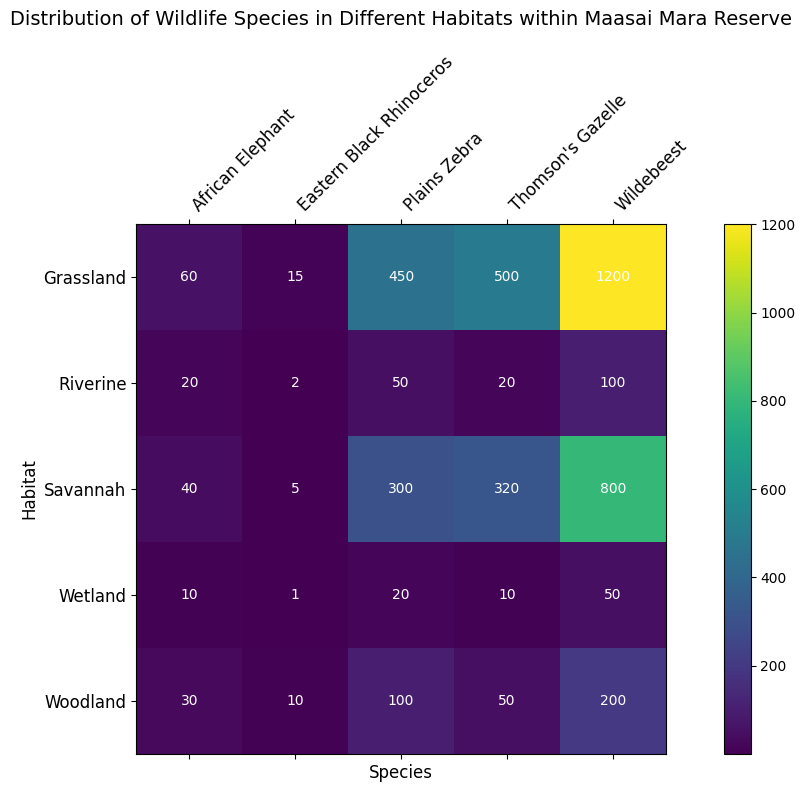What's the total count of all species in the Grassland habitat? In the Grassland row, sum the counts of all the species: 15 (Eastern Black Rhinoceros) + 450 (Plains Zebra) + 500 (Thomson's Gazelle) + 1200 (Wildebeest) + 60 (African Elephant).
Answer: 2225 Which species has the highest count in the Savannah habitat? Look at the counts in the Savannah row and identify the species with the highest number. Wildebeest has the highest count with 800.
Answer: Wildebeest What is the difference in count between Thomson's Gazelle in the Woodland and the Savannah habitats? Subtract the count in the Woodland (50) from the count in the Savannah (320). The difference is 320 - 50 = 270.
Answer: 270 Which habitat has the least number of Eastern Black Rhinoceros? Compare the counts of Eastern Black Rhinoceros across all habitats. Riverine has the least with 2.
Answer: Riverine How does the count of African Elephants in the Riverine compare to those in Wetland? Compare the counts of African Elephants in the Riverine (20) and Wetland (10). 20 is greater than 10.
Answer: Riverine has more Which species has the smallest count in the Wetland habitat? Identify the species with the smallest number in the Wetland row. Eastern Black Rhinoceros has the smallest count with 1.
Answer: Eastern Black Rhinoceros What's the total count of all species across the Riverine and Wetland habitats? Sum all the counts from Riverine and Wetland rows: 2 + 50 + 20 + 100 + 20 + 1 + 20 + 10 + 50 + 10. The total is 283.
Answer: 283 Which habitat has the highest overall count when considering all species together? Compare the total counts of all species across all habitats. Grassland has the highest overall count: 2225.
Answer: Grassland What is the average count of Plains Zebra across all habitats? Sum the counts of Plains Zebra across all habitats: 450 + 300 + 100 + 50 + 20, which is 920. Then divide by the number of habitats, which is 5. 920 / 5 = 184.
Answer: 184 How does the coloration of the Wildebeest count cells change from Grassland to Wetland? Observe the color gradient in Wildebeest count cells from Grassland (darkest color) to Wetland (lightest color). As the count decreases, the color lightens from Grassland to Wetland.
Answer: The color lightens 